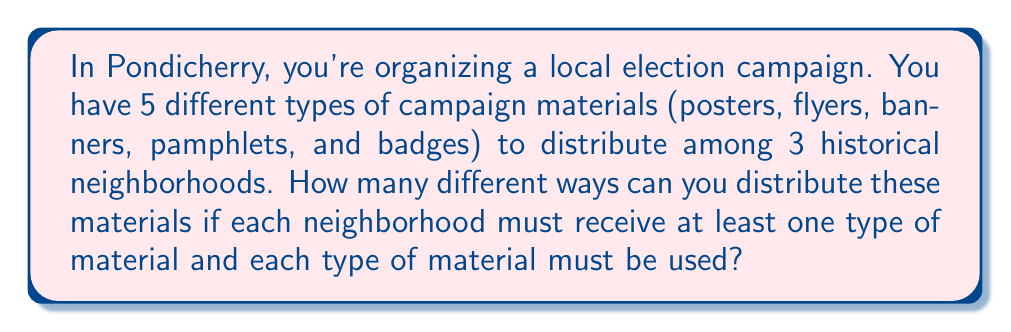Show me your answer to this math problem. To solve this problem, we can use the concept of Stirling numbers of the second kind and the multiplication principle. Let's break it down step-by-step:

1) First, we need to calculate the number of ways to partition 5 distinct objects (campaign materials) into 3 non-empty subsets (neighborhoods). This is given by the Stirling number of the second kind, denoted as $\stirling{5}{3}$.

2) The formula for this Stirling number is:

   $$\stirling{5}{3} = \frac{1}{3!}\sum_{i=0}^3 (-1)^i \binom{3}{i}(3-i)^5$$

3) Expanding this:
   $$\stirling{5}{3} = \frac{1}{6}[(3^5) - 3(2^5) + 3(1^5) - 0]$$
   $$= \frac{1}{6}[243 - 96 + 3]$$
   $$= \frac{1}{6}[150] = 25$$

4) Now, for each of these 25 partitions, we need to consider how many ways we can assign these partitions to the 3 specific neighborhoods. This is simply 3! = 6 ways.

5) By the multiplication principle, the total number of ways to distribute the materials is:

   $$25 \times 6 = 150$$

Therefore, there are 150 different ways to distribute the campaign materials to the three historical neighborhoods of Pondicherry.
Answer: 150 